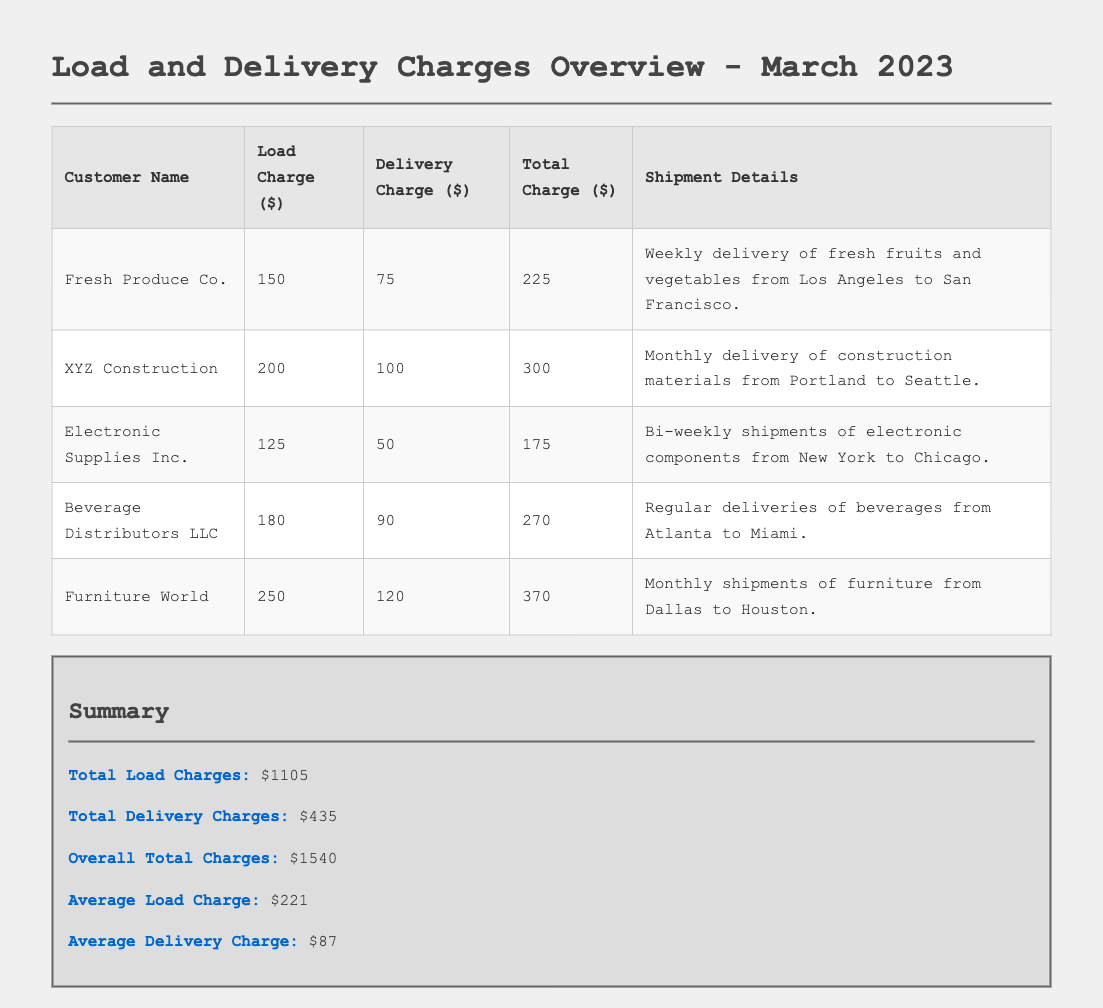What is the customer name with the highest load charge? The customer with the highest load charge is Furniture World, which has a load charge of $250.
Answer: Furniture World What is the total delivery charge for all customers? The total delivery charge is the sum of the delivery charges for all customers, which is $75 + $100 + $50 + $90 + $120 = $435.
Answer: $435 How many customers are listed in the document? There are five customers listed in the document.
Answer: 5 What is the overall total charges for March 2023? The overall total charges are stated as $1540 in the summary section of the document.
Answer: $1540 What is the average load charge? The average load charge is calculated as the total load charges divided by the number of customers, which is $1105 / 5 = $221.
Answer: $221 What is the load charge for Beverage Distributors LLC? The load charge for Beverage Distributors LLC is $180.
Answer: $180 Which customer has the lowest total charge? Electronic Supplies Inc. has the lowest total charge of $175.
Answer: Electronic Supplies Inc What is the delivery charge for Fresh Produce Co.? The delivery charge for Fresh Produce Co. is $75.
Answer: $75 